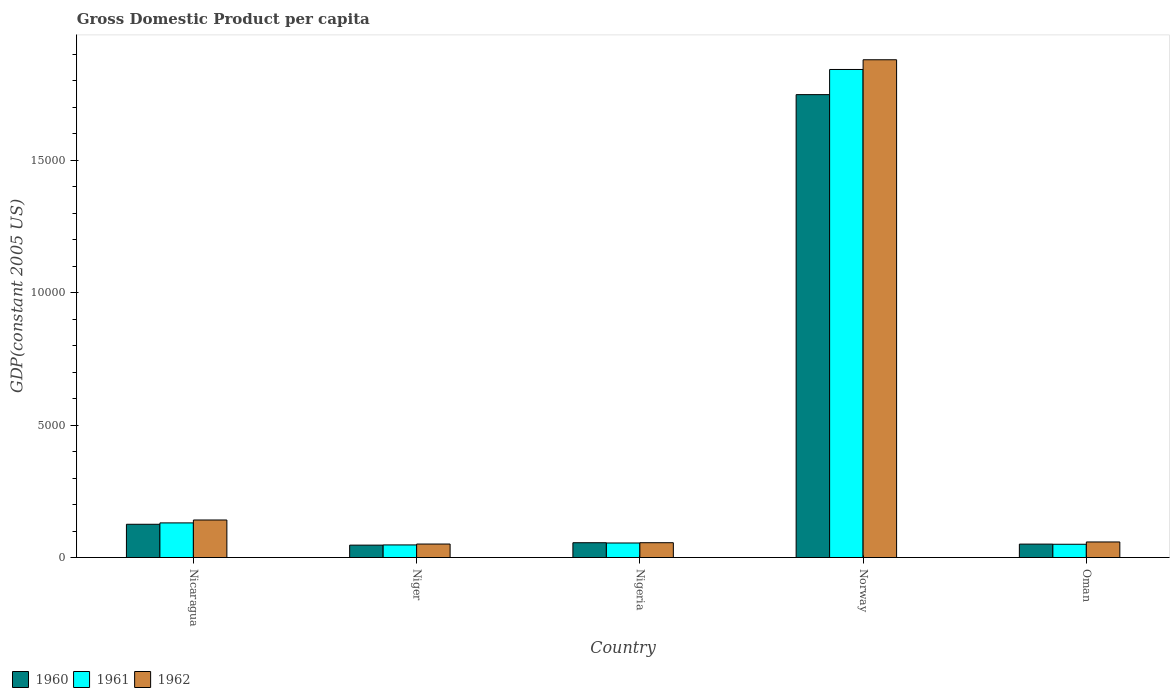How many groups of bars are there?
Ensure brevity in your answer.  5. Are the number of bars on each tick of the X-axis equal?
Your answer should be very brief. Yes. How many bars are there on the 4th tick from the left?
Your response must be concise. 3. How many bars are there on the 4th tick from the right?
Offer a very short reply. 3. What is the label of the 1st group of bars from the left?
Ensure brevity in your answer.  Nicaragua. What is the GDP per capita in 1960 in Oman?
Keep it short and to the point. 507.14. Across all countries, what is the maximum GDP per capita in 1961?
Provide a succinct answer. 1.84e+04. Across all countries, what is the minimum GDP per capita in 1962?
Give a very brief answer. 509.6. In which country was the GDP per capita in 1962 minimum?
Make the answer very short. Niger. What is the total GDP per capita in 1961 in the graph?
Make the answer very short. 2.13e+04. What is the difference between the GDP per capita in 1960 in Nicaragua and that in Oman?
Your answer should be very brief. 748.89. What is the difference between the GDP per capita in 1961 in Nigeria and the GDP per capita in 1962 in Norway?
Provide a succinct answer. -1.83e+04. What is the average GDP per capita in 1962 per country?
Make the answer very short. 4374.97. What is the difference between the GDP per capita of/in 1961 and GDP per capita of/in 1960 in Nigeria?
Keep it short and to the point. -10.25. In how many countries, is the GDP per capita in 1960 greater than 12000 US$?
Give a very brief answer. 1. What is the ratio of the GDP per capita in 1962 in Nicaragua to that in Norway?
Your answer should be very brief. 0.08. What is the difference between the highest and the second highest GDP per capita in 1962?
Your answer should be compact. 1.74e+04. What is the difference between the highest and the lowest GDP per capita in 1962?
Provide a succinct answer. 1.83e+04. Are all the bars in the graph horizontal?
Make the answer very short. No. Are the values on the major ticks of Y-axis written in scientific E-notation?
Provide a short and direct response. No. Where does the legend appear in the graph?
Your answer should be very brief. Bottom left. How many legend labels are there?
Make the answer very short. 3. What is the title of the graph?
Offer a terse response. Gross Domestic Product per capita. Does "1993" appear as one of the legend labels in the graph?
Give a very brief answer. No. What is the label or title of the X-axis?
Your response must be concise. Country. What is the label or title of the Y-axis?
Offer a terse response. GDP(constant 2005 US). What is the GDP(constant 2005 US) in 1960 in Nicaragua?
Your answer should be very brief. 1256.03. What is the GDP(constant 2005 US) of 1961 in Nicaragua?
Your answer should be compact. 1307.92. What is the GDP(constant 2005 US) of 1962 in Nicaragua?
Give a very brief answer. 1417.4. What is the GDP(constant 2005 US) in 1960 in Niger?
Offer a very short reply. 468.22. What is the GDP(constant 2005 US) in 1961 in Niger?
Provide a succinct answer. 475.72. What is the GDP(constant 2005 US) in 1962 in Niger?
Your answer should be compact. 509.6. What is the GDP(constant 2005 US) in 1960 in Nigeria?
Your answer should be compact. 559.19. What is the GDP(constant 2005 US) of 1961 in Nigeria?
Provide a succinct answer. 548.94. What is the GDP(constant 2005 US) in 1962 in Nigeria?
Keep it short and to the point. 559.66. What is the GDP(constant 2005 US) of 1960 in Norway?
Ensure brevity in your answer.  1.75e+04. What is the GDP(constant 2005 US) of 1961 in Norway?
Ensure brevity in your answer.  1.84e+04. What is the GDP(constant 2005 US) in 1962 in Norway?
Keep it short and to the point. 1.88e+04. What is the GDP(constant 2005 US) of 1960 in Oman?
Provide a succinct answer. 507.14. What is the GDP(constant 2005 US) of 1961 in Oman?
Your response must be concise. 500.97. What is the GDP(constant 2005 US) in 1962 in Oman?
Keep it short and to the point. 587.62. Across all countries, what is the maximum GDP(constant 2005 US) of 1960?
Offer a terse response. 1.75e+04. Across all countries, what is the maximum GDP(constant 2005 US) of 1961?
Your answer should be very brief. 1.84e+04. Across all countries, what is the maximum GDP(constant 2005 US) of 1962?
Offer a very short reply. 1.88e+04. Across all countries, what is the minimum GDP(constant 2005 US) in 1960?
Give a very brief answer. 468.22. Across all countries, what is the minimum GDP(constant 2005 US) of 1961?
Give a very brief answer. 475.72. Across all countries, what is the minimum GDP(constant 2005 US) of 1962?
Ensure brevity in your answer.  509.6. What is the total GDP(constant 2005 US) of 1960 in the graph?
Provide a succinct answer. 2.03e+04. What is the total GDP(constant 2005 US) in 1961 in the graph?
Your answer should be compact. 2.13e+04. What is the total GDP(constant 2005 US) of 1962 in the graph?
Your response must be concise. 2.19e+04. What is the difference between the GDP(constant 2005 US) in 1960 in Nicaragua and that in Niger?
Offer a very short reply. 787.8. What is the difference between the GDP(constant 2005 US) of 1961 in Nicaragua and that in Niger?
Your answer should be very brief. 832.2. What is the difference between the GDP(constant 2005 US) of 1962 in Nicaragua and that in Niger?
Keep it short and to the point. 907.8. What is the difference between the GDP(constant 2005 US) of 1960 in Nicaragua and that in Nigeria?
Offer a terse response. 696.83. What is the difference between the GDP(constant 2005 US) in 1961 in Nicaragua and that in Nigeria?
Your answer should be very brief. 758.98. What is the difference between the GDP(constant 2005 US) of 1962 in Nicaragua and that in Nigeria?
Provide a succinct answer. 857.74. What is the difference between the GDP(constant 2005 US) in 1960 in Nicaragua and that in Norway?
Make the answer very short. -1.62e+04. What is the difference between the GDP(constant 2005 US) of 1961 in Nicaragua and that in Norway?
Give a very brief answer. -1.71e+04. What is the difference between the GDP(constant 2005 US) in 1962 in Nicaragua and that in Norway?
Provide a succinct answer. -1.74e+04. What is the difference between the GDP(constant 2005 US) of 1960 in Nicaragua and that in Oman?
Give a very brief answer. 748.89. What is the difference between the GDP(constant 2005 US) of 1961 in Nicaragua and that in Oman?
Ensure brevity in your answer.  806.95. What is the difference between the GDP(constant 2005 US) of 1962 in Nicaragua and that in Oman?
Your answer should be very brief. 829.78. What is the difference between the GDP(constant 2005 US) in 1960 in Niger and that in Nigeria?
Your response must be concise. -90.97. What is the difference between the GDP(constant 2005 US) of 1961 in Niger and that in Nigeria?
Provide a short and direct response. -73.22. What is the difference between the GDP(constant 2005 US) in 1962 in Niger and that in Nigeria?
Your response must be concise. -50.06. What is the difference between the GDP(constant 2005 US) in 1960 in Niger and that in Norway?
Your answer should be compact. -1.70e+04. What is the difference between the GDP(constant 2005 US) of 1961 in Niger and that in Norway?
Make the answer very short. -1.80e+04. What is the difference between the GDP(constant 2005 US) of 1962 in Niger and that in Norway?
Provide a short and direct response. -1.83e+04. What is the difference between the GDP(constant 2005 US) in 1960 in Niger and that in Oman?
Your answer should be compact. -38.91. What is the difference between the GDP(constant 2005 US) of 1961 in Niger and that in Oman?
Offer a terse response. -25.25. What is the difference between the GDP(constant 2005 US) in 1962 in Niger and that in Oman?
Your answer should be compact. -78.02. What is the difference between the GDP(constant 2005 US) in 1960 in Nigeria and that in Norway?
Keep it short and to the point. -1.69e+04. What is the difference between the GDP(constant 2005 US) of 1961 in Nigeria and that in Norway?
Your answer should be compact. -1.79e+04. What is the difference between the GDP(constant 2005 US) in 1962 in Nigeria and that in Norway?
Give a very brief answer. -1.82e+04. What is the difference between the GDP(constant 2005 US) of 1960 in Nigeria and that in Oman?
Your response must be concise. 52.06. What is the difference between the GDP(constant 2005 US) in 1961 in Nigeria and that in Oman?
Ensure brevity in your answer.  47.97. What is the difference between the GDP(constant 2005 US) in 1962 in Nigeria and that in Oman?
Make the answer very short. -27.96. What is the difference between the GDP(constant 2005 US) of 1960 in Norway and that in Oman?
Offer a very short reply. 1.70e+04. What is the difference between the GDP(constant 2005 US) in 1961 in Norway and that in Oman?
Your answer should be compact. 1.79e+04. What is the difference between the GDP(constant 2005 US) in 1962 in Norway and that in Oman?
Your answer should be compact. 1.82e+04. What is the difference between the GDP(constant 2005 US) of 1960 in Nicaragua and the GDP(constant 2005 US) of 1961 in Niger?
Your answer should be compact. 780.3. What is the difference between the GDP(constant 2005 US) of 1960 in Nicaragua and the GDP(constant 2005 US) of 1962 in Niger?
Your answer should be very brief. 746.43. What is the difference between the GDP(constant 2005 US) in 1961 in Nicaragua and the GDP(constant 2005 US) in 1962 in Niger?
Your response must be concise. 798.32. What is the difference between the GDP(constant 2005 US) of 1960 in Nicaragua and the GDP(constant 2005 US) of 1961 in Nigeria?
Make the answer very short. 707.08. What is the difference between the GDP(constant 2005 US) in 1960 in Nicaragua and the GDP(constant 2005 US) in 1962 in Nigeria?
Offer a very short reply. 696.37. What is the difference between the GDP(constant 2005 US) of 1961 in Nicaragua and the GDP(constant 2005 US) of 1962 in Nigeria?
Your answer should be compact. 748.26. What is the difference between the GDP(constant 2005 US) of 1960 in Nicaragua and the GDP(constant 2005 US) of 1961 in Norway?
Your answer should be very brief. -1.72e+04. What is the difference between the GDP(constant 2005 US) in 1960 in Nicaragua and the GDP(constant 2005 US) in 1962 in Norway?
Your answer should be compact. -1.75e+04. What is the difference between the GDP(constant 2005 US) of 1961 in Nicaragua and the GDP(constant 2005 US) of 1962 in Norway?
Provide a succinct answer. -1.75e+04. What is the difference between the GDP(constant 2005 US) in 1960 in Nicaragua and the GDP(constant 2005 US) in 1961 in Oman?
Your response must be concise. 755.06. What is the difference between the GDP(constant 2005 US) of 1960 in Nicaragua and the GDP(constant 2005 US) of 1962 in Oman?
Your answer should be compact. 668.41. What is the difference between the GDP(constant 2005 US) in 1961 in Nicaragua and the GDP(constant 2005 US) in 1962 in Oman?
Offer a terse response. 720.31. What is the difference between the GDP(constant 2005 US) in 1960 in Niger and the GDP(constant 2005 US) in 1961 in Nigeria?
Offer a very short reply. -80.72. What is the difference between the GDP(constant 2005 US) in 1960 in Niger and the GDP(constant 2005 US) in 1962 in Nigeria?
Offer a very short reply. -91.43. What is the difference between the GDP(constant 2005 US) of 1961 in Niger and the GDP(constant 2005 US) of 1962 in Nigeria?
Provide a succinct answer. -83.94. What is the difference between the GDP(constant 2005 US) of 1960 in Niger and the GDP(constant 2005 US) of 1961 in Norway?
Your answer should be compact. -1.80e+04. What is the difference between the GDP(constant 2005 US) in 1960 in Niger and the GDP(constant 2005 US) in 1962 in Norway?
Your answer should be very brief. -1.83e+04. What is the difference between the GDP(constant 2005 US) of 1961 in Niger and the GDP(constant 2005 US) of 1962 in Norway?
Your answer should be very brief. -1.83e+04. What is the difference between the GDP(constant 2005 US) of 1960 in Niger and the GDP(constant 2005 US) of 1961 in Oman?
Your response must be concise. -32.75. What is the difference between the GDP(constant 2005 US) of 1960 in Niger and the GDP(constant 2005 US) of 1962 in Oman?
Your answer should be compact. -119.39. What is the difference between the GDP(constant 2005 US) of 1961 in Niger and the GDP(constant 2005 US) of 1962 in Oman?
Offer a very short reply. -111.89. What is the difference between the GDP(constant 2005 US) in 1960 in Nigeria and the GDP(constant 2005 US) in 1961 in Norway?
Your answer should be very brief. -1.79e+04. What is the difference between the GDP(constant 2005 US) in 1960 in Nigeria and the GDP(constant 2005 US) in 1962 in Norway?
Provide a succinct answer. -1.82e+04. What is the difference between the GDP(constant 2005 US) of 1961 in Nigeria and the GDP(constant 2005 US) of 1962 in Norway?
Provide a short and direct response. -1.83e+04. What is the difference between the GDP(constant 2005 US) of 1960 in Nigeria and the GDP(constant 2005 US) of 1961 in Oman?
Your answer should be compact. 58.22. What is the difference between the GDP(constant 2005 US) of 1960 in Nigeria and the GDP(constant 2005 US) of 1962 in Oman?
Your answer should be compact. -28.42. What is the difference between the GDP(constant 2005 US) of 1961 in Nigeria and the GDP(constant 2005 US) of 1962 in Oman?
Offer a very short reply. -38.67. What is the difference between the GDP(constant 2005 US) of 1960 in Norway and the GDP(constant 2005 US) of 1961 in Oman?
Your answer should be very brief. 1.70e+04. What is the difference between the GDP(constant 2005 US) of 1960 in Norway and the GDP(constant 2005 US) of 1962 in Oman?
Your answer should be very brief. 1.69e+04. What is the difference between the GDP(constant 2005 US) of 1961 in Norway and the GDP(constant 2005 US) of 1962 in Oman?
Your response must be concise. 1.78e+04. What is the average GDP(constant 2005 US) of 1960 per country?
Provide a short and direct response. 4054.86. What is the average GDP(constant 2005 US) of 1961 per country?
Keep it short and to the point. 4253.42. What is the average GDP(constant 2005 US) in 1962 per country?
Give a very brief answer. 4374.97. What is the difference between the GDP(constant 2005 US) of 1960 and GDP(constant 2005 US) of 1961 in Nicaragua?
Keep it short and to the point. -51.9. What is the difference between the GDP(constant 2005 US) of 1960 and GDP(constant 2005 US) of 1962 in Nicaragua?
Provide a succinct answer. -161.37. What is the difference between the GDP(constant 2005 US) of 1961 and GDP(constant 2005 US) of 1962 in Nicaragua?
Give a very brief answer. -109.48. What is the difference between the GDP(constant 2005 US) of 1960 and GDP(constant 2005 US) of 1961 in Niger?
Provide a short and direct response. -7.5. What is the difference between the GDP(constant 2005 US) of 1960 and GDP(constant 2005 US) of 1962 in Niger?
Offer a very short reply. -41.37. What is the difference between the GDP(constant 2005 US) of 1961 and GDP(constant 2005 US) of 1962 in Niger?
Your response must be concise. -33.88. What is the difference between the GDP(constant 2005 US) of 1960 and GDP(constant 2005 US) of 1961 in Nigeria?
Your answer should be very brief. 10.25. What is the difference between the GDP(constant 2005 US) in 1960 and GDP(constant 2005 US) in 1962 in Nigeria?
Offer a terse response. -0.46. What is the difference between the GDP(constant 2005 US) of 1961 and GDP(constant 2005 US) of 1962 in Nigeria?
Keep it short and to the point. -10.71. What is the difference between the GDP(constant 2005 US) in 1960 and GDP(constant 2005 US) in 1961 in Norway?
Your response must be concise. -949.8. What is the difference between the GDP(constant 2005 US) in 1960 and GDP(constant 2005 US) in 1962 in Norway?
Your answer should be very brief. -1316.86. What is the difference between the GDP(constant 2005 US) of 1961 and GDP(constant 2005 US) of 1962 in Norway?
Provide a short and direct response. -367.06. What is the difference between the GDP(constant 2005 US) of 1960 and GDP(constant 2005 US) of 1961 in Oman?
Provide a short and direct response. 6.17. What is the difference between the GDP(constant 2005 US) in 1960 and GDP(constant 2005 US) in 1962 in Oman?
Give a very brief answer. -80.48. What is the difference between the GDP(constant 2005 US) in 1961 and GDP(constant 2005 US) in 1962 in Oman?
Give a very brief answer. -86.64. What is the ratio of the GDP(constant 2005 US) of 1960 in Nicaragua to that in Niger?
Your answer should be very brief. 2.68. What is the ratio of the GDP(constant 2005 US) in 1961 in Nicaragua to that in Niger?
Provide a short and direct response. 2.75. What is the ratio of the GDP(constant 2005 US) of 1962 in Nicaragua to that in Niger?
Offer a terse response. 2.78. What is the ratio of the GDP(constant 2005 US) in 1960 in Nicaragua to that in Nigeria?
Provide a short and direct response. 2.25. What is the ratio of the GDP(constant 2005 US) of 1961 in Nicaragua to that in Nigeria?
Give a very brief answer. 2.38. What is the ratio of the GDP(constant 2005 US) in 1962 in Nicaragua to that in Nigeria?
Provide a succinct answer. 2.53. What is the ratio of the GDP(constant 2005 US) in 1960 in Nicaragua to that in Norway?
Ensure brevity in your answer.  0.07. What is the ratio of the GDP(constant 2005 US) in 1961 in Nicaragua to that in Norway?
Your answer should be very brief. 0.07. What is the ratio of the GDP(constant 2005 US) in 1962 in Nicaragua to that in Norway?
Your answer should be compact. 0.08. What is the ratio of the GDP(constant 2005 US) of 1960 in Nicaragua to that in Oman?
Your answer should be compact. 2.48. What is the ratio of the GDP(constant 2005 US) in 1961 in Nicaragua to that in Oman?
Your response must be concise. 2.61. What is the ratio of the GDP(constant 2005 US) in 1962 in Nicaragua to that in Oman?
Offer a terse response. 2.41. What is the ratio of the GDP(constant 2005 US) in 1960 in Niger to that in Nigeria?
Offer a very short reply. 0.84. What is the ratio of the GDP(constant 2005 US) in 1961 in Niger to that in Nigeria?
Ensure brevity in your answer.  0.87. What is the ratio of the GDP(constant 2005 US) of 1962 in Niger to that in Nigeria?
Give a very brief answer. 0.91. What is the ratio of the GDP(constant 2005 US) of 1960 in Niger to that in Norway?
Your answer should be very brief. 0.03. What is the ratio of the GDP(constant 2005 US) of 1961 in Niger to that in Norway?
Offer a very short reply. 0.03. What is the ratio of the GDP(constant 2005 US) in 1962 in Niger to that in Norway?
Your answer should be very brief. 0.03. What is the ratio of the GDP(constant 2005 US) in 1960 in Niger to that in Oman?
Ensure brevity in your answer.  0.92. What is the ratio of the GDP(constant 2005 US) in 1961 in Niger to that in Oman?
Your response must be concise. 0.95. What is the ratio of the GDP(constant 2005 US) of 1962 in Niger to that in Oman?
Your answer should be very brief. 0.87. What is the ratio of the GDP(constant 2005 US) in 1960 in Nigeria to that in Norway?
Offer a terse response. 0.03. What is the ratio of the GDP(constant 2005 US) in 1961 in Nigeria to that in Norway?
Offer a very short reply. 0.03. What is the ratio of the GDP(constant 2005 US) in 1962 in Nigeria to that in Norway?
Offer a very short reply. 0.03. What is the ratio of the GDP(constant 2005 US) in 1960 in Nigeria to that in Oman?
Offer a terse response. 1.1. What is the ratio of the GDP(constant 2005 US) of 1961 in Nigeria to that in Oman?
Your response must be concise. 1.1. What is the ratio of the GDP(constant 2005 US) of 1960 in Norway to that in Oman?
Your answer should be compact. 34.48. What is the ratio of the GDP(constant 2005 US) of 1961 in Norway to that in Oman?
Give a very brief answer. 36.8. What is the ratio of the GDP(constant 2005 US) in 1962 in Norway to that in Oman?
Give a very brief answer. 31.99. What is the difference between the highest and the second highest GDP(constant 2005 US) in 1960?
Offer a terse response. 1.62e+04. What is the difference between the highest and the second highest GDP(constant 2005 US) in 1961?
Ensure brevity in your answer.  1.71e+04. What is the difference between the highest and the second highest GDP(constant 2005 US) of 1962?
Make the answer very short. 1.74e+04. What is the difference between the highest and the lowest GDP(constant 2005 US) of 1960?
Provide a short and direct response. 1.70e+04. What is the difference between the highest and the lowest GDP(constant 2005 US) in 1961?
Offer a terse response. 1.80e+04. What is the difference between the highest and the lowest GDP(constant 2005 US) of 1962?
Keep it short and to the point. 1.83e+04. 